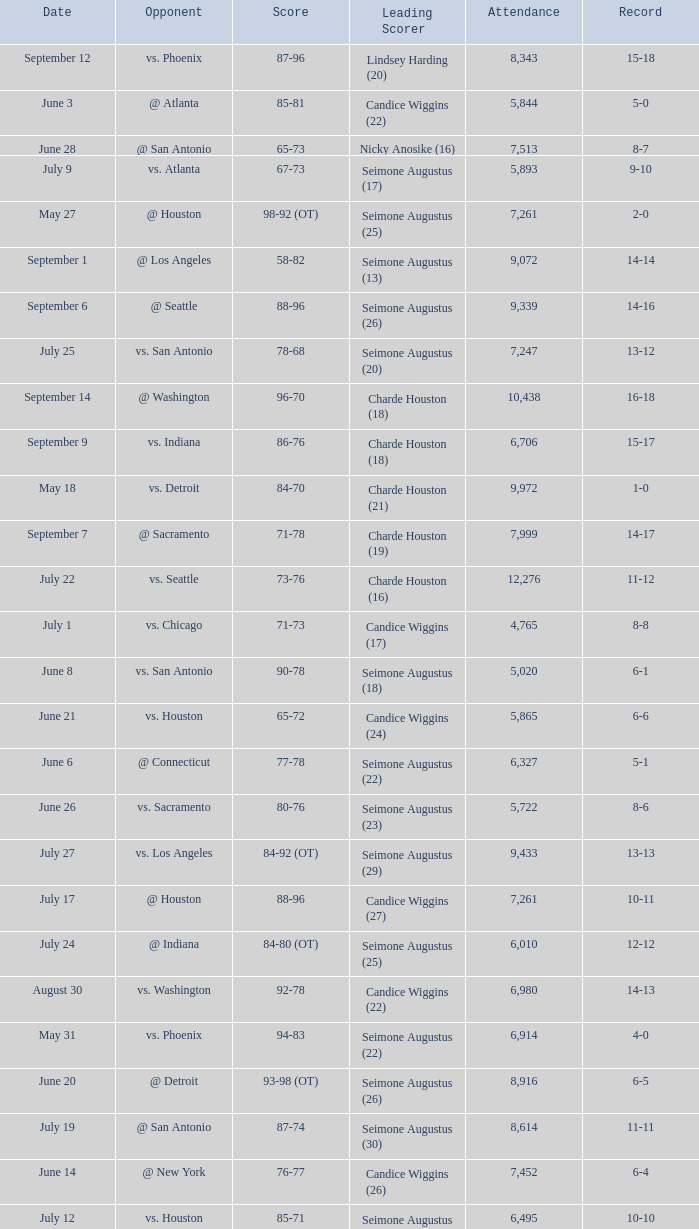Which Leading Scorer has an Opponent of @ seattle, and a Record of 14-16? Seimone Augustus (26). Can you parse all the data within this table? {'header': ['Date', 'Opponent', 'Score', 'Leading Scorer', 'Attendance', 'Record'], 'rows': [['September 12', 'vs. Phoenix', '87-96', 'Lindsey Harding (20)', '8,343', '15-18'], ['June 3', '@ Atlanta', '85-81', 'Candice Wiggins (22)', '5,844', '5-0'], ['June 28', '@ San Antonio', '65-73', 'Nicky Anosike (16)', '7,513', '8-7'], ['July 9', 'vs. Atlanta', '67-73', 'Seimone Augustus (17)', '5,893', '9-10'], ['May 27', '@ Houston', '98-92 (OT)', 'Seimone Augustus (25)', '7,261', '2-0'], ['September 1', '@ Los Angeles', '58-82', 'Seimone Augustus (13)', '9,072', '14-14'], ['September 6', '@ Seattle', '88-96', 'Seimone Augustus (26)', '9,339', '14-16'], ['July 25', 'vs. San Antonio', '78-68', 'Seimone Augustus (20)', '7,247', '13-12'], ['September 14', '@ Washington', '96-70', 'Charde Houston (18)', '10,438', '16-18'], ['September 9', 'vs. Indiana', '86-76', 'Charde Houston (18)', '6,706', '15-17'], ['May 18', 'vs. Detroit', '84-70', 'Charde Houston (21)', '9,972', '1-0'], ['September 7', '@ Sacramento', '71-78', 'Charde Houston (19)', '7,999', '14-17'], ['July 22', 'vs. Seattle', '73-76', 'Charde Houston (16)', '12,276', '11-12'], ['July 1', 'vs. Chicago', '71-73', 'Candice Wiggins (17)', '4,765', '8-8'], ['June 8', 'vs. San Antonio', '90-78', 'Seimone Augustus (18)', '5,020', '6-1'], ['June 21', 'vs. Houston', '65-72', 'Candice Wiggins (24)', '5,865', '6-6'], ['June 6', '@ Connecticut', '77-78', 'Seimone Augustus (22)', '6,327', '5-1'], ['June 26', 'vs. Sacramento', '80-76', 'Seimone Augustus (23)', '5,722', '8-6'], ['July 27', 'vs. Los Angeles', '84-92 (OT)', 'Seimone Augustus (29)', '9,433', '13-13'], ['July 17', '@ Houston', '88-96', 'Candice Wiggins (27)', '7,261', '10-11'], ['July 24', '@ Indiana', '84-80 (OT)', 'Seimone Augustus (25)', '6,010', '12-12'], ['August 30', 'vs. Washington', '92-78', 'Candice Wiggins (22)', '6,980', '14-13'], ['May 31', 'vs. Phoenix', '94-83', 'Seimone Augustus (22)', '6,914', '4-0'], ['June 20', '@ Detroit', '93-98 (OT)', 'Seimone Augustus (26)', '8,916', '6-5'], ['July 19', '@ San Antonio', '87-74', 'Seimone Augustus (30)', '8,614', '11-11'], ['June 14', '@ New York', '76-77', 'Candice Wiggins (26)', '7,452', '6-4'], ['July 12', 'vs. Houston', '85-71', 'Seimone Augustus (27)', '6,495', '10-10'], ['May 29', '@ Chicago', '75-69', 'Seimone Augustus (19)', '3,014', '3-0'], ['September 3', '@ Phoenix', '96-103', 'Seimone Augustus (27)', '7,722', '14-15'], ['June 12', 'vs. Sacramento', '78-82', 'Seimone Augustus (21)', '4,875', '6-3'], ['June 24', 'vs. New York', '91-69', 'Seimone Augustus (21)', '6,280', '7-6'], ['July 5', '@ Seattle', '71-96', 'Nicky Anosike (15)', '7,553', '9-9'], ['July 3', '@ Los Angeles', '88-70', 'Seimone Augustus (29)', '8,587', '9-8'], ['June 10', 'vs. Connecticut', '66-75', 'Candice Wiggins (22)', '7,186', '6-2']]} 